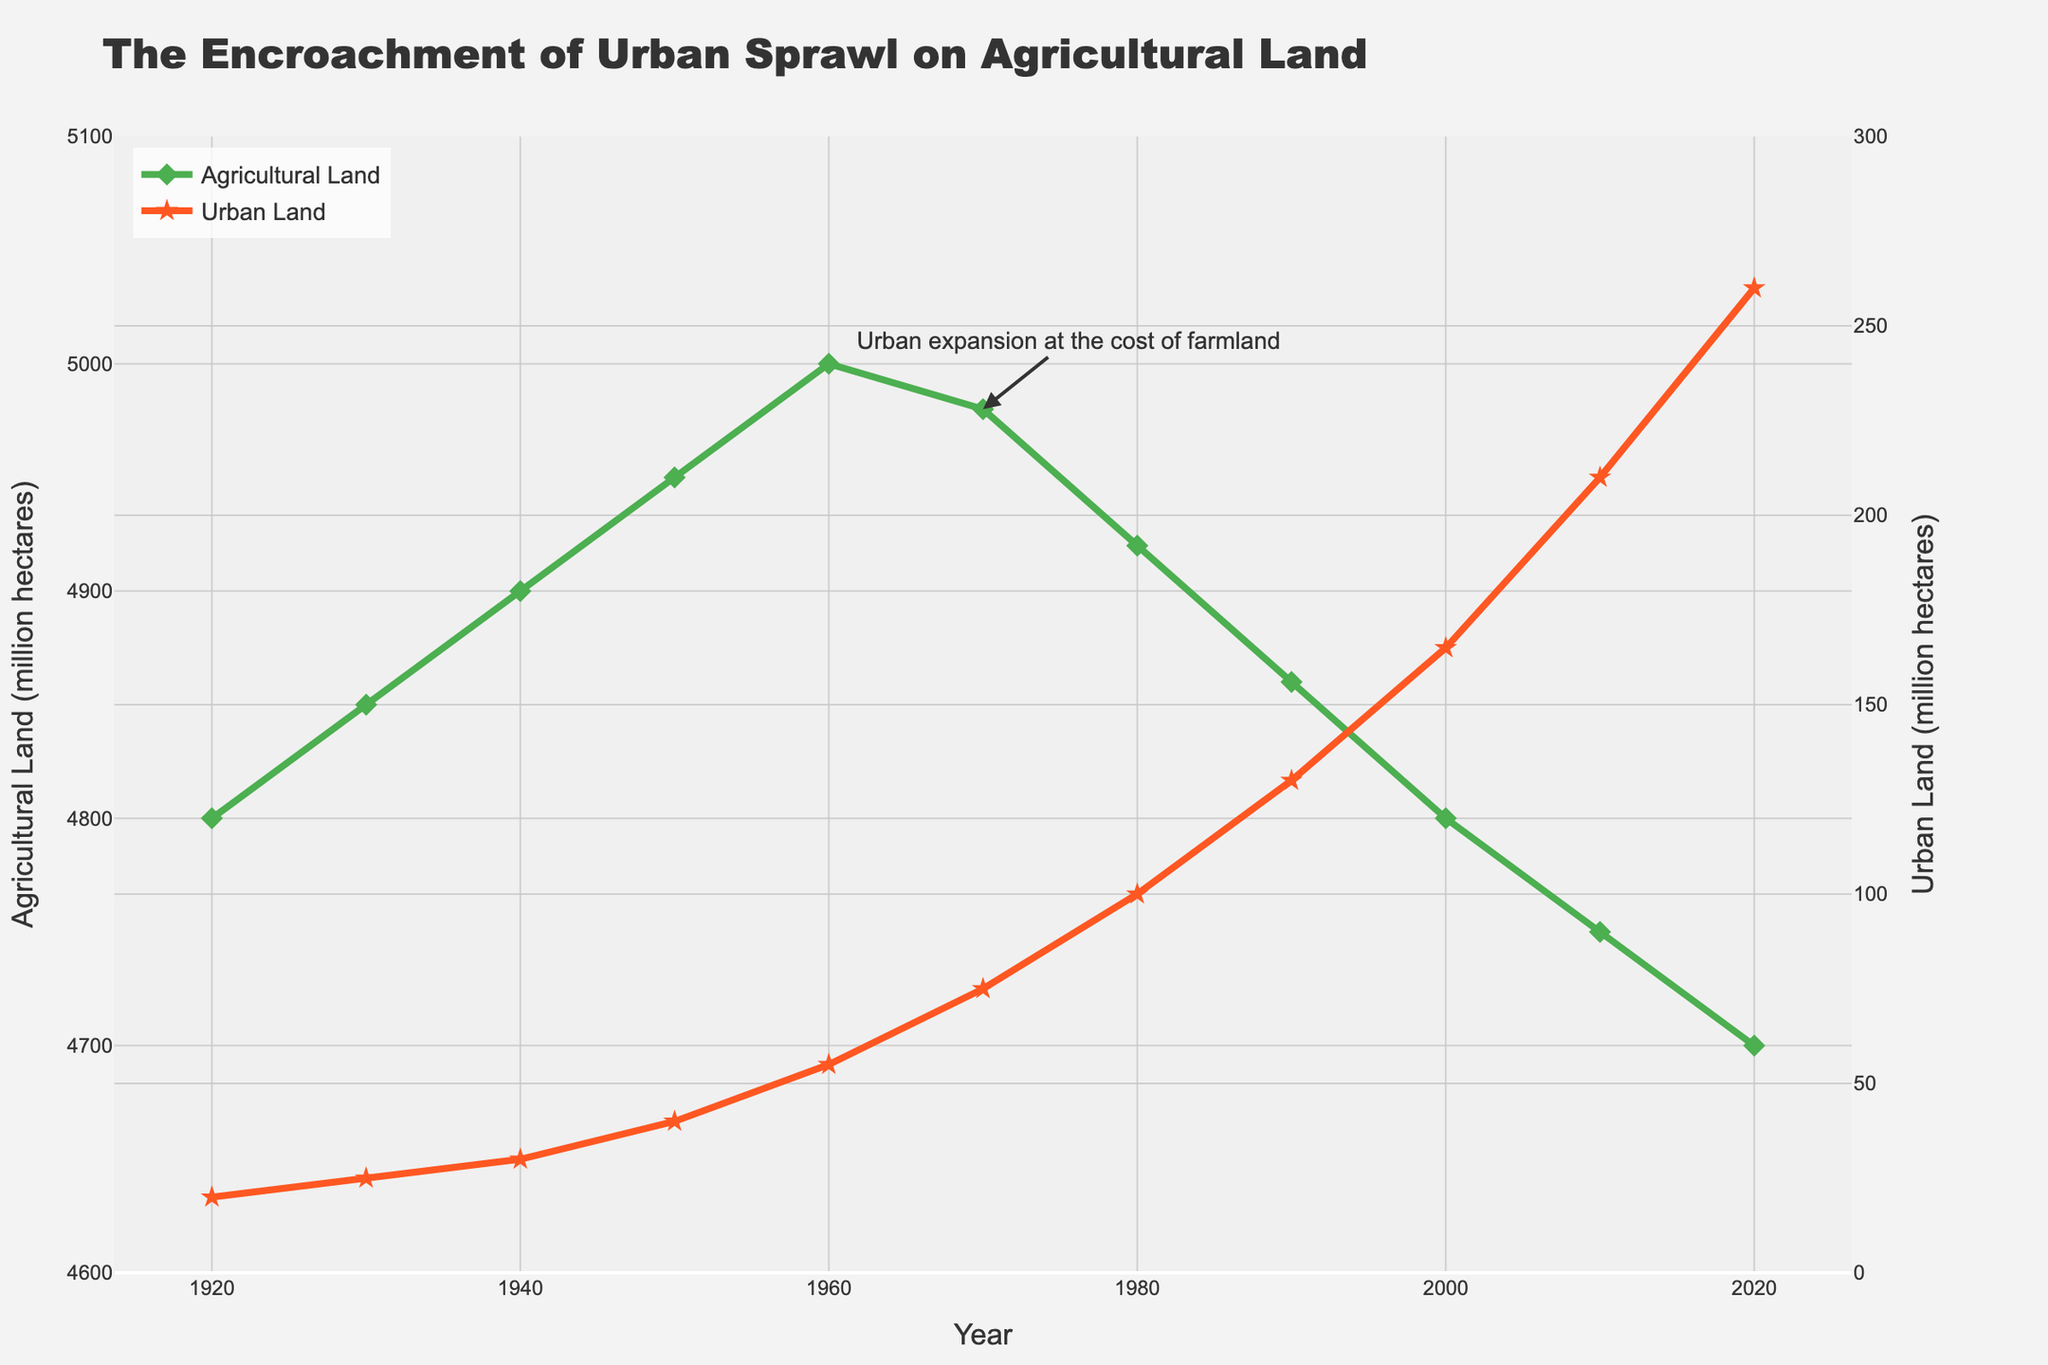What's the difference in agricultural land from 1920 to 2020? Observe the values for agricultural land in 1920 (4800 million hectares) and 2020 (4700 million hectares). Subtract the 2020 value from the 1920 value: 4800 - 4700 = 100 million hectares.
Answer: 100 million hectares By how much did urban land increase from 1930 to 2010? Look at the urban land values in 1930 (25 million hectares) and 2010 (210 million hectares). Subtract the 1930 value from the 2010 value: 210 - 25 = 185 million hectares.
Answer: 185 million hectares Which year marks the first noticeable decline in agricultural land? Scan the agricultural land data points year by year. Notice that agricultural land starts to decline after 1960 (5000 million hectares). So the first noticeable drop is between 1960 and 1970.
Answer: 1970 When did urban land exceed 100 million hectares for the first time? Check the urban land values year by year until the value first surpasses 100 million hectares. The year when it first exceeds 100 million hectares is 1980.
Answer: 1980 What is the combined total of agricultural and urban land in 1950? Add the values for agricultural land (4950 million hectares) and urban land (40 million hectares) in 1950: 4950 + 40 = 4990 million hectares.
Answer: 4990 million hectares During which decade did urban land experience the highest growth rate? Observe the urban land values across each decade and calculate the increment. The highest growth rate occurred between 2000 (165 million hectares) and 2010 (210 million hectares): 210 - 165 = 45 million hectares.
Answer: 2000-2010 What were the values of both agricultural and urban land in 2000? Refer to the line chart to find the values for the year 2000. Agricultural land is 4800 million hectares, and urban land is 165 million hectares.
Answer: Agricultural land: 4800 million hectares, Urban land: 165 million hectares Compare the trend between agricultural and urban land from 1940 to 1970. What difference do you observe? Agricultural land increased slightly from 4900 to 4980 million hectares, while urban land grew more markedly from 30 to 75 million hectares. Hence, urban land increased at a faster rate compared to the relatively stable agricultural land.
Answer: Urban growth is faster than agricultural What is the average agricultural land in the dataset? Calculate the average by summing up all the agricultural land values and dividing by the number of years: (4800 + 4850 + 4900 + 4950 + 5000 + 4980 + 4920 + 4860 + 4800 + 4750 + 4700) / 11 = 4864.54 million hectares (rounded to two decimal places).
Answer: 4864.54 million hectares 